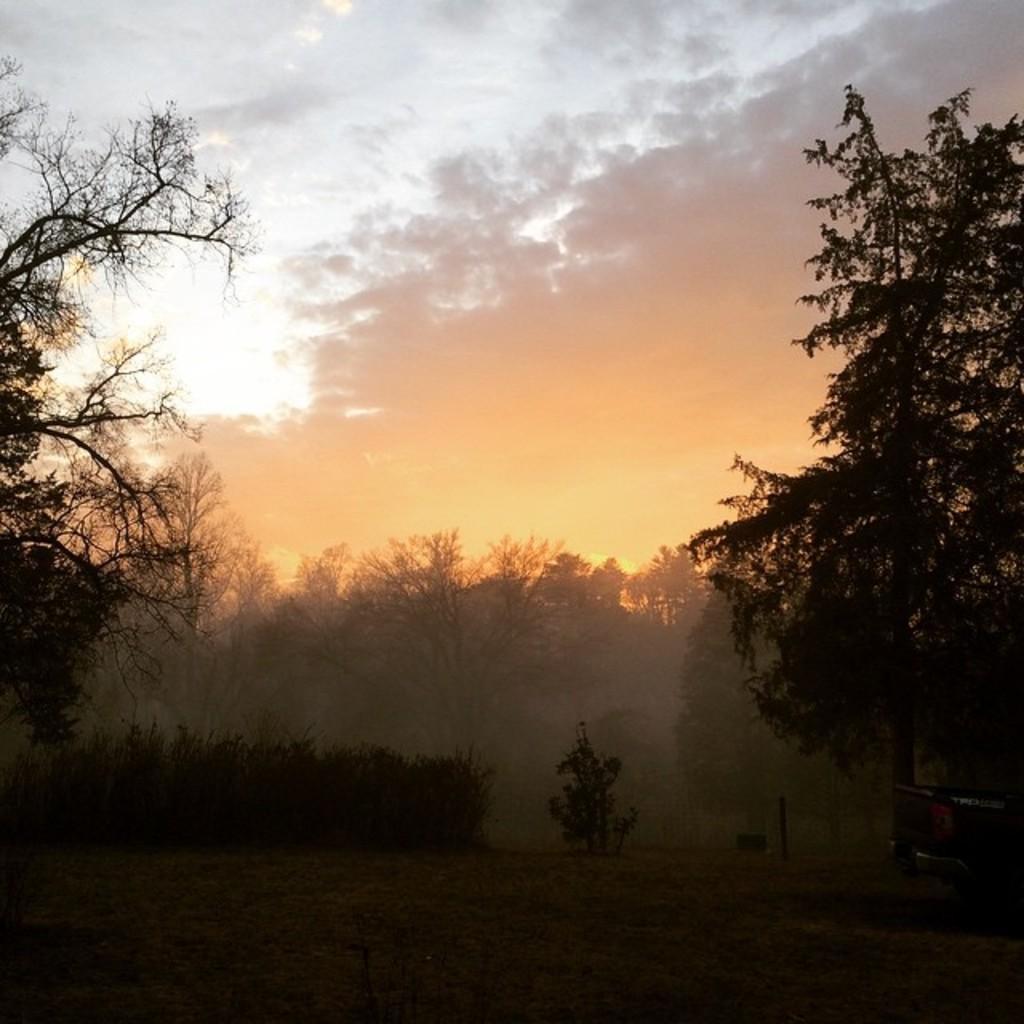Could you give a brief overview of what you see in this image? This image consists of many trees. At the top, there are clouds in the sky. At the bottom, there is green grass on the ground. 